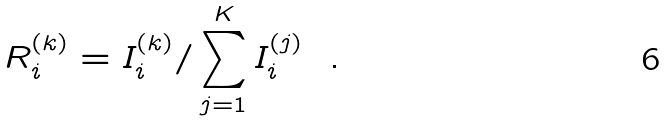<formula> <loc_0><loc_0><loc_500><loc_500>R ^ { ( k ) } _ { i } = I _ { i } ^ { ( k ) } / \sum _ { j = 1 } ^ { K } I _ { i } ^ { ( j ) } \ \ .</formula> 